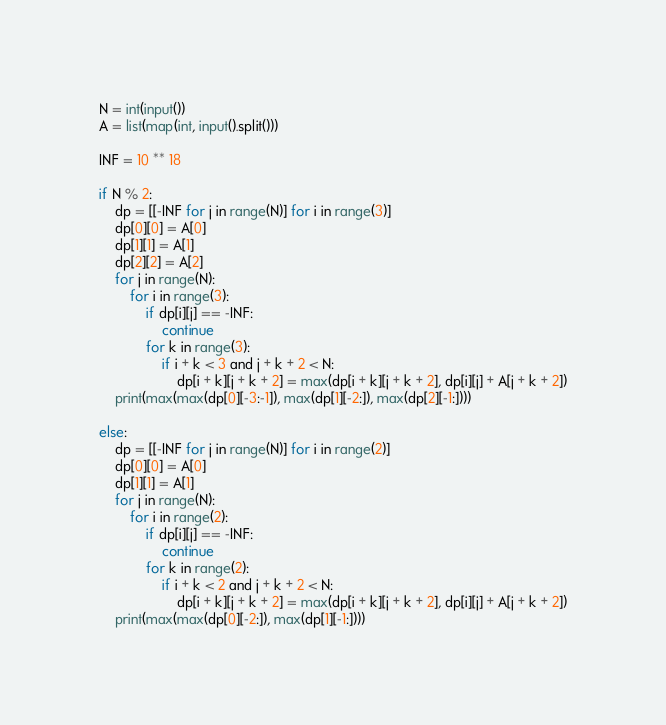<code> <loc_0><loc_0><loc_500><loc_500><_Python_>N = int(input())
A = list(map(int, input().split()))

INF = 10 ** 18

if N % 2:
    dp = [[-INF for j in range(N)] for i in range(3)]
    dp[0][0] = A[0]
    dp[1][1] = A[1]
    dp[2][2] = A[2]
    for j in range(N):
        for i in range(3):
            if dp[i][j] == -INF:
                continue
            for k in range(3):
                if i + k < 3 and j + k + 2 < N:
                    dp[i + k][j + k + 2] = max(dp[i + k][j + k + 2], dp[i][j] + A[j + k + 2])
    print(max(max(dp[0][-3:-1]), max(dp[1][-2:]), max(dp[2][-1:])))
    
else:
    dp = [[-INF for j in range(N)] for i in range(2)]
    dp[0][0] = A[0]
    dp[1][1] = A[1]
    for j in range(N):
        for i in range(2):
            if dp[i][j] == -INF:
                continue
            for k in range(2):
                if i + k < 2 and j + k + 2 < N:
                    dp[i + k][j + k + 2] = max(dp[i + k][j + k + 2], dp[i][j] + A[j + k + 2])
    print(max(max(dp[0][-2:]), max(dp[1][-1:])))</code> 